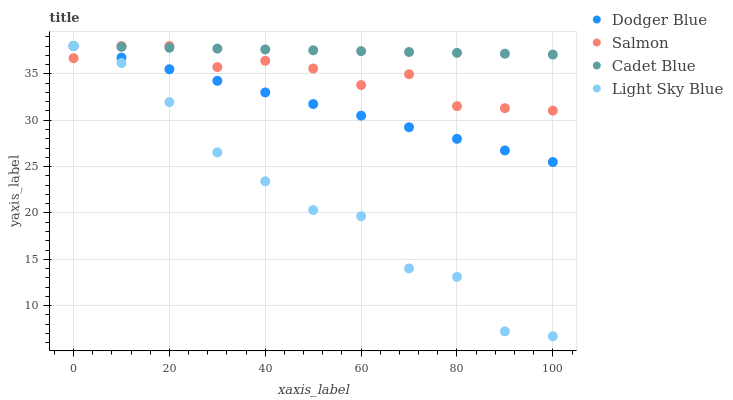Does Light Sky Blue have the minimum area under the curve?
Answer yes or no. Yes. Does Cadet Blue have the maximum area under the curve?
Answer yes or no. Yes. Does Dodger Blue have the minimum area under the curve?
Answer yes or no. No. Does Dodger Blue have the maximum area under the curve?
Answer yes or no. No. Is Dodger Blue the smoothest?
Answer yes or no. Yes. Is Light Sky Blue the roughest?
Answer yes or no. Yes. Is Cadet Blue the smoothest?
Answer yes or no. No. Is Cadet Blue the roughest?
Answer yes or no. No. Does Light Sky Blue have the lowest value?
Answer yes or no. Yes. Does Dodger Blue have the lowest value?
Answer yes or no. No. Does Light Sky Blue have the highest value?
Answer yes or no. Yes. Does Salmon intersect Dodger Blue?
Answer yes or no. Yes. Is Salmon less than Dodger Blue?
Answer yes or no. No. Is Salmon greater than Dodger Blue?
Answer yes or no. No. 